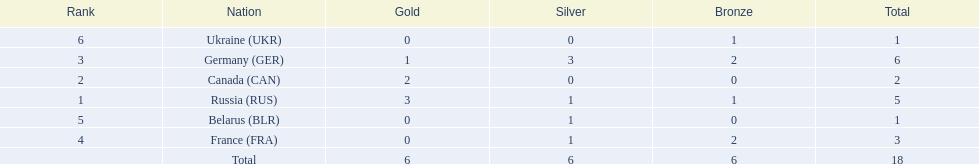Which countries competed in the 1995 biathlon? Russia (RUS), Canada (CAN), Germany (GER), France (FRA), Belarus (BLR), Ukraine (UKR). How many medals in total did they win? 5, 2, 6, 3, 1, 1. And which country had the most? Germany (GER). 